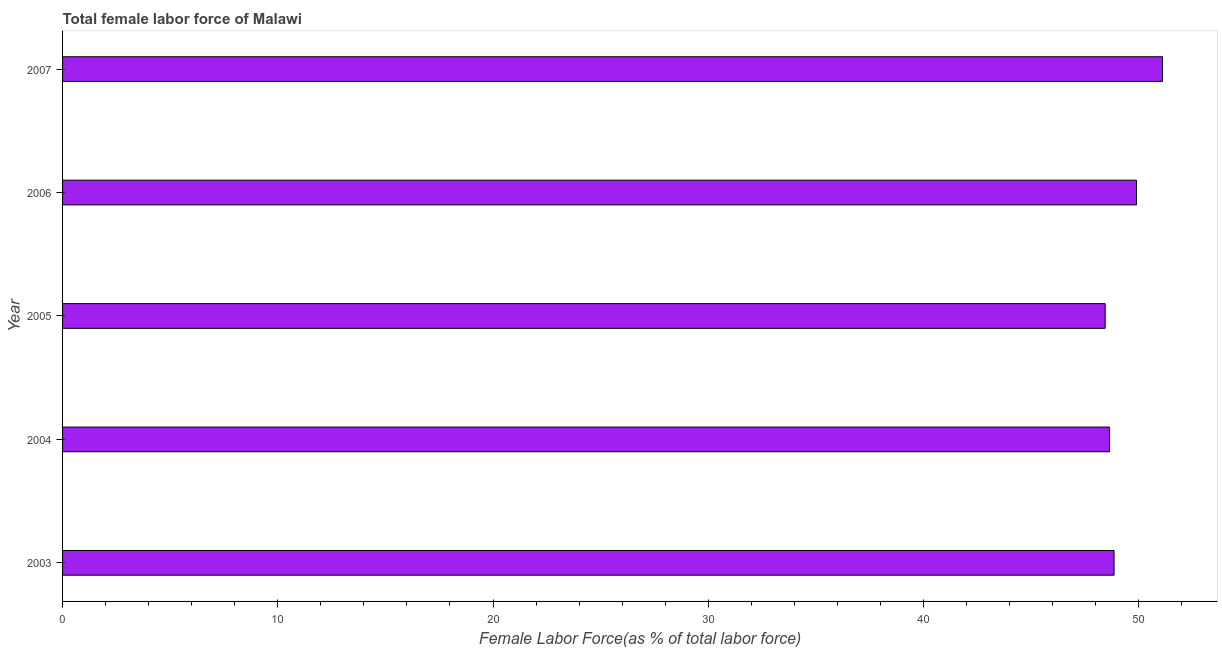Does the graph contain grids?
Provide a succinct answer. No. What is the title of the graph?
Make the answer very short. Total female labor force of Malawi. What is the label or title of the X-axis?
Give a very brief answer. Female Labor Force(as % of total labor force). What is the total female labor force in 2005?
Provide a short and direct response. 48.44. Across all years, what is the maximum total female labor force?
Provide a succinct answer. 51.11. Across all years, what is the minimum total female labor force?
Your answer should be very brief. 48.44. What is the sum of the total female labor force?
Provide a succinct answer. 246.95. What is the difference between the total female labor force in 2005 and 2006?
Give a very brief answer. -1.46. What is the average total female labor force per year?
Offer a very short reply. 49.39. What is the median total female labor force?
Offer a terse response. 48.86. What is the ratio of the total female labor force in 2004 to that in 2005?
Offer a very short reply. 1. Is the total female labor force in 2006 less than that in 2007?
Give a very brief answer. Yes. Is the difference between the total female labor force in 2004 and 2007 greater than the difference between any two years?
Provide a short and direct response. No. What is the difference between the highest and the second highest total female labor force?
Provide a succinct answer. 1.21. Is the sum of the total female labor force in 2005 and 2007 greater than the maximum total female labor force across all years?
Offer a terse response. Yes. What is the difference between the highest and the lowest total female labor force?
Your answer should be compact. 2.66. How many bars are there?
Give a very brief answer. 5. Are all the bars in the graph horizontal?
Make the answer very short. Yes. How many years are there in the graph?
Offer a terse response. 5. Are the values on the major ticks of X-axis written in scientific E-notation?
Make the answer very short. No. What is the Female Labor Force(as % of total labor force) of 2003?
Keep it short and to the point. 48.86. What is the Female Labor Force(as % of total labor force) of 2004?
Ensure brevity in your answer.  48.65. What is the Female Labor Force(as % of total labor force) of 2005?
Make the answer very short. 48.44. What is the Female Labor Force(as % of total labor force) of 2006?
Give a very brief answer. 49.9. What is the Female Labor Force(as % of total labor force) of 2007?
Your response must be concise. 51.11. What is the difference between the Female Labor Force(as % of total labor force) in 2003 and 2004?
Your answer should be very brief. 0.21. What is the difference between the Female Labor Force(as % of total labor force) in 2003 and 2005?
Provide a succinct answer. 0.41. What is the difference between the Female Labor Force(as % of total labor force) in 2003 and 2006?
Your answer should be compact. -1.04. What is the difference between the Female Labor Force(as % of total labor force) in 2003 and 2007?
Ensure brevity in your answer.  -2.25. What is the difference between the Female Labor Force(as % of total labor force) in 2004 and 2005?
Your response must be concise. 0.2. What is the difference between the Female Labor Force(as % of total labor force) in 2004 and 2006?
Your response must be concise. -1.25. What is the difference between the Female Labor Force(as % of total labor force) in 2004 and 2007?
Provide a short and direct response. -2.46. What is the difference between the Female Labor Force(as % of total labor force) in 2005 and 2006?
Offer a terse response. -1.45. What is the difference between the Female Labor Force(as % of total labor force) in 2005 and 2007?
Give a very brief answer. -2.66. What is the difference between the Female Labor Force(as % of total labor force) in 2006 and 2007?
Provide a succinct answer. -1.21. What is the ratio of the Female Labor Force(as % of total labor force) in 2003 to that in 2004?
Make the answer very short. 1. What is the ratio of the Female Labor Force(as % of total labor force) in 2003 to that in 2005?
Offer a terse response. 1.01. What is the ratio of the Female Labor Force(as % of total labor force) in 2003 to that in 2007?
Your response must be concise. 0.96. What is the ratio of the Female Labor Force(as % of total labor force) in 2004 to that in 2006?
Provide a succinct answer. 0.97. What is the ratio of the Female Labor Force(as % of total labor force) in 2004 to that in 2007?
Your answer should be compact. 0.95. What is the ratio of the Female Labor Force(as % of total labor force) in 2005 to that in 2007?
Make the answer very short. 0.95. What is the ratio of the Female Labor Force(as % of total labor force) in 2006 to that in 2007?
Offer a terse response. 0.98. 